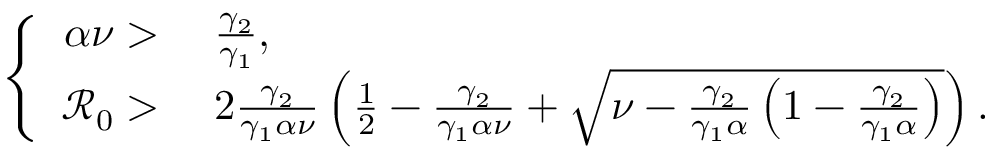<formula> <loc_0><loc_0><loc_500><loc_500>\left \{ \begin{array} { r l } { \alpha \nu > } & { \, \frac { \gamma _ { 2 } } { \gamma _ { 1 } } , } \\ { \mathcal { R } _ { 0 } > } & { \, 2 \frac { \gamma _ { 2 } } { \gamma _ { 1 } \alpha \nu } \left ( \frac { 1 } { 2 } - \frac { \gamma _ { 2 } } { \gamma _ { 1 } \alpha \nu } + \sqrt { \nu - \frac { \gamma _ { 2 } } { \gamma _ { 1 } \alpha } \left ( 1 - \frac { \gamma _ { 2 } } { \gamma _ { 1 } \alpha } \right ) } \right ) . } \end{array}</formula> 